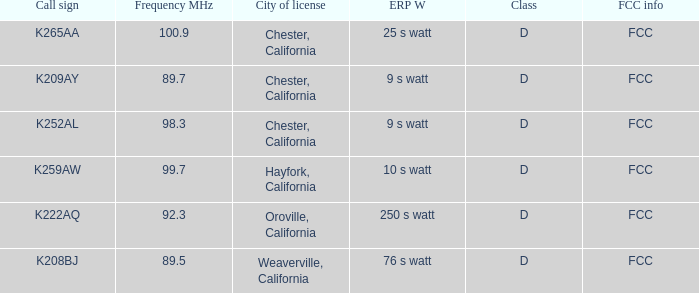Name the call sign with frequency of 89.5 K208BJ. 